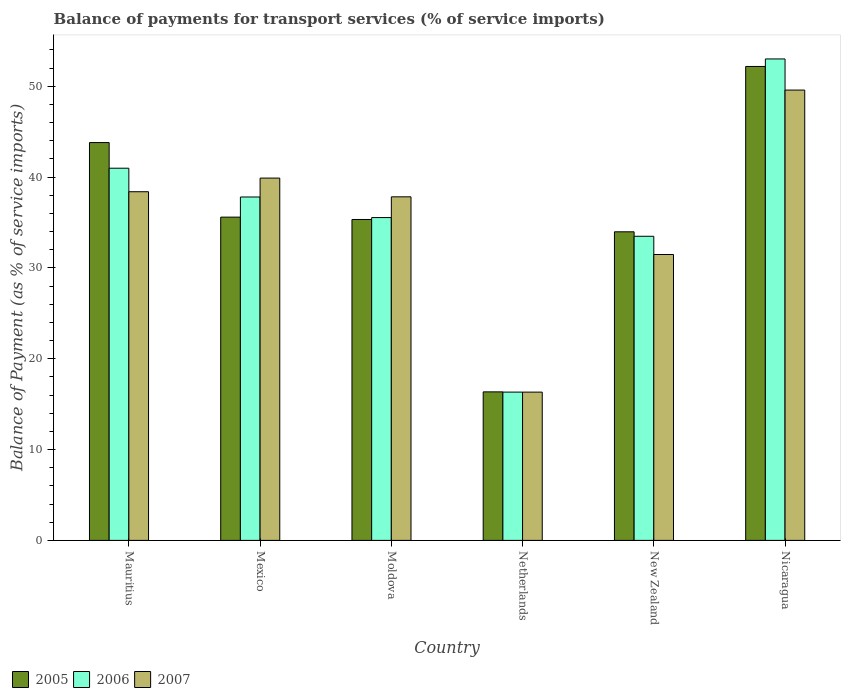How many different coloured bars are there?
Provide a succinct answer. 3. Are the number of bars per tick equal to the number of legend labels?
Make the answer very short. Yes. How many bars are there on the 4th tick from the left?
Offer a terse response. 3. What is the label of the 1st group of bars from the left?
Keep it short and to the point. Mauritius. In how many cases, is the number of bars for a given country not equal to the number of legend labels?
Your answer should be compact. 0. What is the balance of payments for transport services in 2006 in Mexico?
Your answer should be very brief. 37.81. Across all countries, what is the maximum balance of payments for transport services in 2006?
Your answer should be compact. 53.01. Across all countries, what is the minimum balance of payments for transport services in 2007?
Provide a succinct answer. 16.33. In which country was the balance of payments for transport services in 2007 maximum?
Give a very brief answer. Nicaragua. In which country was the balance of payments for transport services in 2006 minimum?
Provide a succinct answer. Netherlands. What is the total balance of payments for transport services in 2005 in the graph?
Provide a succinct answer. 217.26. What is the difference between the balance of payments for transport services in 2006 in Mexico and that in New Zealand?
Your answer should be very brief. 4.33. What is the difference between the balance of payments for transport services in 2005 in New Zealand and the balance of payments for transport services in 2006 in Mexico?
Give a very brief answer. -3.83. What is the average balance of payments for transport services in 2006 per country?
Keep it short and to the point. 36.2. What is the difference between the balance of payments for transport services of/in 2007 and balance of payments for transport services of/in 2006 in Mexico?
Your answer should be compact. 2.08. What is the ratio of the balance of payments for transport services in 2006 in Mauritius to that in Nicaragua?
Make the answer very short. 0.77. Is the balance of payments for transport services in 2006 in Mexico less than that in Moldova?
Give a very brief answer. No. Is the difference between the balance of payments for transport services in 2007 in Mexico and New Zealand greater than the difference between the balance of payments for transport services in 2006 in Mexico and New Zealand?
Provide a succinct answer. Yes. What is the difference between the highest and the second highest balance of payments for transport services in 2005?
Offer a terse response. -8.21. What is the difference between the highest and the lowest balance of payments for transport services in 2005?
Ensure brevity in your answer.  35.83. Is the sum of the balance of payments for transport services in 2007 in Moldova and New Zealand greater than the maximum balance of payments for transport services in 2006 across all countries?
Provide a short and direct response. Yes. What does the 2nd bar from the left in Netherlands represents?
Your response must be concise. 2006. What does the 2nd bar from the right in Nicaragua represents?
Make the answer very short. 2006. Is it the case that in every country, the sum of the balance of payments for transport services in 2007 and balance of payments for transport services in 2006 is greater than the balance of payments for transport services in 2005?
Ensure brevity in your answer.  Yes. How many countries are there in the graph?
Your answer should be very brief. 6. What is the difference between two consecutive major ticks on the Y-axis?
Provide a short and direct response. 10. Are the values on the major ticks of Y-axis written in scientific E-notation?
Offer a very short reply. No. Does the graph contain grids?
Offer a terse response. No. How many legend labels are there?
Make the answer very short. 3. How are the legend labels stacked?
Give a very brief answer. Horizontal. What is the title of the graph?
Keep it short and to the point. Balance of payments for transport services (% of service imports). What is the label or title of the Y-axis?
Offer a terse response. Balance of Payment (as % of service imports). What is the Balance of Payment (as % of service imports) of 2005 in Mauritius?
Ensure brevity in your answer.  43.81. What is the Balance of Payment (as % of service imports) in 2006 in Mauritius?
Ensure brevity in your answer.  40.98. What is the Balance of Payment (as % of service imports) of 2007 in Mauritius?
Give a very brief answer. 38.39. What is the Balance of Payment (as % of service imports) of 2005 in Mexico?
Make the answer very short. 35.6. What is the Balance of Payment (as % of service imports) in 2006 in Mexico?
Provide a short and direct response. 37.81. What is the Balance of Payment (as % of service imports) of 2007 in Mexico?
Provide a succinct answer. 39.9. What is the Balance of Payment (as % of service imports) of 2005 in Moldova?
Make the answer very short. 35.34. What is the Balance of Payment (as % of service imports) of 2006 in Moldova?
Your response must be concise. 35.55. What is the Balance of Payment (as % of service imports) of 2007 in Moldova?
Give a very brief answer. 37.83. What is the Balance of Payment (as % of service imports) in 2005 in Netherlands?
Offer a very short reply. 16.35. What is the Balance of Payment (as % of service imports) of 2006 in Netherlands?
Your answer should be compact. 16.33. What is the Balance of Payment (as % of service imports) in 2007 in Netherlands?
Provide a succinct answer. 16.33. What is the Balance of Payment (as % of service imports) in 2005 in New Zealand?
Provide a short and direct response. 33.98. What is the Balance of Payment (as % of service imports) in 2006 in New Zealand?
Provide a succinct answer. 33.49. What is the Balance of Payment (as % of service imports) in 2007 in New Zealand?
Offer a terse response. 31.48. What is the Balance of Payment (as % of service imports) in 2005 in Nicaragua?
Offer a terse response. 52.19. What is the Balance of Payment (as % of service imports) in 2006 in Nicaragua?
Give a very brief answer. 53.01. What is the Balance of Payment (as % of service imports) of 2007 in Nicaragua?
Make the answer very short. 49.59. Across all countries, what is the maximum Balance of Payment (as % of service imports) of 2005?
Your answer should be very brief. 52.19. Across all countries, what is the maximum Balance of Payment (as % of service imports) of 2006?
Your answer should be very brief. 53.01. Across all countries, what is the maximum Balance of Payment (as % of service imports) of 2007?
Ensure brevity in your answer.  49.59. Across all countries, what is the minimum Balance of Payment (as % of service imports) in 2005?
Provide a short and direct response. 16.35. Across all countries, what is the minimum Balance of Payment (as % of service imports) of 2006?
Your response must be concise. 16.33. Across all countries, what is the minimum Balance of Payment (as % of service imports) in 2007?
Your answer should be very brief. 16.33. What is the total Balance of Payment (as % of service imports) in 2005 in the graph?
Your response must be concise. 217.26. What is the total Balance of Payment (as % of service imports) in 2006 in the graph?
Offer a very short reply. 217.18. What is the total Balance of Payment (as % of service imports) of 2007 in the graph?
Your answer should be compact. 213.52. What is the difference between the Balance of Payment (as % of service imports) of 2005 in Mauritius and that in Mexico?
Make the answer very short. 8.21. What is the difference between the Balance of Payment (as % of service imports) of 2006 in Mauritius and that in Mexico?
Your response must be concise. 3.17. What is the difference between the Balance of Payment (as % of service imports) of 2007 in Mauritius and that in Mexico?
Make the answer very short. -1.5. What is the difference between the Balance of Payment (as % of service imports) of 2005 in Mauritius and that in Moldova?
Your answer should be very brief. 8.47. What is the difference between the Balance of Payment (as % of service imports) of 2006 in Mauritius and that in Moldova?
Your response must be concise. 5.43. What is the difference between the Balance of Payment (as % of service imports) of 2007 in Mauritius and that in Moldova?
Ensure brevity in your answer.  0.56. What is the difference between the Balance of Payment (as % of service imports) in 2005 in Mauritius and that in Netherlands?
Your response must be concise. 27.45. What is the difference between the Balance of Payment (as % of service imports) of 2006 in Mauritius and that in Netherlands?
Your answer should be compact. 24.65. What is the difference between the Balance of Payment (as % of service imports) in 2007 in Mauritius and that in Netherlands?
Provide a succinct answer. 22.07. What is the difference between the Balance of Payment (as % of service imports) in 2005 in Mauritius and that in New Zealand?
Your answer should be very brief. 9.83. What is the difference between the Balance of Payment (as % of service imports) of 2006 in Mauritius and that in New Zealand?
Your answer should be compact. 7.49. What is the difference between the Balance of Payment (as % of service imports) of 2007 in Mauritius and that in New Zealand?
Your answer should be compact. 6.91. What is the difference between the Balance of Payment (as % of service imports) of 2005 in Mauritius and that in Nicaragua?
Give a very brief answer. -8.38. What is the difference between the Balance of Payment (as % of service imports) in 2006 in Mauritius and that in Nicaragua?
Give a very brief answer. -12.03. What is the difference between the Balance of Payment (as % of service imports) in 2007 in Mauritius and that in Nicaragua?
Provide a succinct answer. -11.19. What is the difference between the Balance of Payment (as % of service imports) of 2005 in Mexico and that in Moldova?
Offer a very short reply. 0.26. What is the difference between the Balance of Payment (as % of service imports) in 2006 in Mexico and that in Moldova?
Keep it short and to the point. 2.27. What is the difference between the Balance of Payment (as % of service imports) of 2007 in Mexico and that in Moldova?
Your answer should be compact. 2.06. What is the difference between the Balance of Payment (as % of service imports) of 2005 in Mexico and that in Netherlands?
Make the answer very short. 19.24. What is the difference between the Balance of Payment (as % of service imports) in 2006 in Mexico and that in Netherlands?
Ensure brevity in your answer.  21.48. What is the difference between the Balance of Payment (as % of service imports) in 2007 in Mexico and that in Netherlands?
Provide a succinct answer. 23.57. What is the difference between the Balance of Payment (as % of service imports) of 2005 in Mexico and that in New Zealand?
Provide a succinct answer. 1.62. What is the difference between the Balance of Payment (as % of service imports) of 2006 in Mexico and that in New Zealand?
Make the answer very short. 4.33. What is the difference between the Balance of Payment (as % of service imports) of 2007 in Mexico and that in New Zealand?
Give a very brief answer. 8.42. What is the difference between the Balance of Payment (as % of service imports) of 2005 in Mexico and that in Nicaragua?
Your answer should be very brief. -16.59. What is the difference between the Balance of Payment (as % of service imports) in 2006 in Mexico and that in Nicaragua?
Your answer should be compact. -15.2. What is the difference between the Balance of Payment (as % of service imports) in 2007 in Mexico and that in Nicaragua?
Provide a short and direct response. -9.69. What is the difference between the Balance of Payment (as % of service imports) of 2005 in Moldova and that in Netherlands?
Your answer should be very brief. 18.98. What is the difference between the Balance of Payment (as % of service imports) in 2006 in Moldova and that in Netherlands?
Your answer should be compact. 19.22. What is the difference between the Balance of Payment (as % of service imports) of 2007 in Moldova and that in Netherlands?
Ensure brevity in your answer.  21.51. What is the difference between the Balance of Payment (as % of service imports) of 2005 in Moldova and that in New Zealand?
Your answer should be compact. 1.36. What is the difference between the Balance of Payment (as % of service imports) in 2006 in Moldova and that in New Zealand?
Your response must be concise. 2.06. What is the difference between the Balance of Payment (as % of service imports) in 2007 in Moldova and that in New Zealand?
Ensure brevity in your answer.  6.35. What is the difference between the Balance of Payment (as % of service imports) of 2005 in Moldova and that in Nicaragua?
Your answer should be compact. -16.85. What is the difference between the Balance of Payment (as % of service imports) of 2006 in Moldova and that in Nicaragua?
Make the answer very short. -17.47. What is the difference between the Balance of Payment (as % of service imports) in 2007 in Moldova and that in Nicaragua?
Your answer should be compact. -11.75. What is the difference between the Balance of Payment (as % of service imports) in 2005 in Netherlands and that in New Zealand?
Your answer should be compact. -17.63. What is the difference between the Balance of Payment (as % of service imports) in 2006 in Netherlands and that in New Zealand?
Ensure brevity in your answer.  -17.16. What is the difference between the Balance of Payment (as % of service imports) in 2007 in Netherlands and that in New Zealand?
Offer a terse response. -15.15. What is the difference between the Balance of Payment (as % of service imports) of 2005 in Netherlands and that in Nicaragua?
Your answer should be very brief. -35.83. What is the difference between the Balance of Payment (as % of service imports) in 2006 in Netherlands and that in Nicaragua?
Your response must be concise. -36.69. What is the difference between the Balance of Payment (as % of service imports) in 2007 in Netherlands and that in Nicaragua?
Your response must be concise. -33.26. What is the difference between the Balance of Payment (as % of service imports) in 2005 in New Zealand and that in Nicaragua?
Your response must be concise. -18.21. What is the difference between the Balance of Payment (as % of service imports) in 2006 in New Zealand and that in Nicaragua?
Offer a terse response. -19.53. What is the difference between the Balance of Payment (as % of service imports) in 2007 in New Zealand and that in Nicaragua?
Offer a terse response. -18.11. What is the difference between the Balance of Payment (as % of service imports) in 2005 in Mauritius and the Balance of Payment (as % of service imports) in 2006 in Mexico?
Offer a terse response. 5.99. What is the difference between the Balance of Payment (as % of service imports) in 2005 in Mauritius and the Balance of Payment (as % of service imports) in 2007 in Mexico?
Provide a short and direct response. 3.91. What is the difference between the Balance of Payment (as % of service imports) in 2006 in Mauritius and the Balance of Payment (as % of service imports) in 2007 in Mexico?
Provide a succinct answer. 1.09. What is the difference between the Balance of Payment (as % of service imports) of 2005 in Mauritius and the Balance of Payment (as % of service imports) of 2006 in Moldova?
Make the answer very short. 8.26. What is the difference between the Balance of Payment (as % of service imports) in 2005 in Mauritius and the Balance of Payment (as % of service imports) in 2007 in Moldova?
Offer a very short reply. 5.97. What is the difference between the Balance of Payment (as % of service imports) of 2006 in Mauritius and the Balance of Payment (as % of service imports) of 2007 in Moldova?
Ensure brevity in your answer.  3.15. What is the difference between the Balance of Payment (as % of service imports) of 2005 in Mauritius and the Balance of Payment (as % of service imports) of 2006 in Netherlands?
Your answer should be compact. 27.48. What is the difference between the Balance of Payment (as % of service imports) in 2005 in Mauritius and the Balance of Payment (as % of service imports) in 2007 in Netherlands?
Make the answer very short. 27.48. What is the difference between the Balance of Payment (as % of service imports) in 2006 in Mauritius and the Balance of Payment (as % of service imports) in 2007 in Netherlands?
Ensure brevity in your answer.  24.65. What is the difference between the Balance of Payment (as % of service imports) in 2005 in Mauritius and the Balance of Payment (as % of service imports) in 2006 in New Zealand?
Provide a succinct answer. 10.32. What is the difference between the Balance of Payment (as % of service imports) in 2005 in Mauritius and the Balance of Payment (as % of service imports) in 2007 in New Zealand?
Make the answer very short. 12.33. What is the difference between the Balance of Payment (as % of service imports) of 2006 in Mauritius and the Balance of Payment (as % of service imports) of 2007 in New Zealand?
Your answer should be very brief. 9.5. What is the difference between the Balance of Payment (as % of service imports) of 2005 in Mauritius and the Balance of Payment (as % of service imports) of 2006 in Nicaragua?
Give a very brief answer. -9.21. What is the difference between the Balance of Payment (as % of service imports) in 2005 in Mauritius and the Balance of Payment (as % of service imports) in 2007 in Nicaragua?
Your answer should be very brief. -5.78. What is the difference between the Balance of Payment (as % of service imports) of 2006 in Mauritius and the Balance of Payment (as % of service imports) of 2007 in Nicaragua?
Your answer should be very brief. -8.61. What is the difference between the Balance of Payment (as % of service imports) in 2005 in Mexico and the Balance of Payment (as % of service imports) in 2006 in Moldova?
Offer a very short reply. 0.05. What is the difference between the Balance of Payment (as % of service imports) in 2005 in Mexico and the Balance of Payment (as % of service imports) in 2007 in Moldova?
Make the answer very short. -2.24. What is the difference between the Balance of Payment (as % of service imports) in 2006 in Mexico and the Balance of Payment (as % of service imports) in 2007 in Moldova?
Make the answer very short. -0.02. What is the difference between the Balance of Payment (as % of service imports) of 2005 in Mexico and the Balance of Payment (as % of service imports) of 2006 in Netherlands?
Keep it short and to the point. 19.27. What is the difference between the Balance of Payment (as % of service imports) of 2005 in Mexico and the Balance of Payment (as % of service imports) of 2007 in Netherlands?
Your response must be concise. 19.27. What is the difference between the Balance of Payment (as % of service imports) of 2006 in Mexico and the Balance of Payment (as % of service imports) of 2007 in Netherlands?
Your answer should be compact. 21.49. What is the difference between the Balance of Payment (as % of service imports) in 2005 in Mexico and the Balance of Payment (as % of service imports) in 2006 in New Zealand?
Ensure brevity in your answer.  2.11. What is the difference between the Balance of Payment (as % of service imports) in 2005 in Mexico and the Balance of Payment (as % of service imports) in 2007 in New Zealand?
Offer a very short reply. 4.12. What is the difference between the Balance of Payment (as % of service imports) of 2006 in Mexico and the Balance of Payment (as % of service imports) of 2007 in New Zealand?
Make the answer very short. 6.33. What is the difference between the Balance of Payment (as % of service imports) of 2005 in Mexico and the Balance of Payment (as % of service imports) of 2006 in Nicaragua?
Provide a succinct answer. -17.42. What is the difference between the Balance of Payment (as % of service imports) in 2005 in Mexico and the Balance of Payment (as % of service imports) in 2007 in Nicaragua?
Make the answer very short. -13.99. What is the difference between the Balance of Payment (as % of service imports) of 2006 in Mexico and the Balance of Payment (as % of service imports) of 2007 in Nicaragua?
Provide a succinct answer. -11.77. What is the difference between the Balance of Payment (as % of service imports) in 2005 in Moldova and the Balance of Payment (as % of service imports) in 2006 in Netherlands?
Offer a terse response. 19.01. What is the difference between the Balance of Payment (as % of service imports) of 2005 in Moldova and the Balance of Payment (as % of service imports) of 2007 in Netherlands?
Provide a short and direct response. 19.01. What is the difference between the Balance of Payment (as % of service imports) of 2006 in Moldova and the Balance of Payment (as % of service imports) of 2007 in Netherlands?
Provide a succinct answer. 19.22. What is the difference between the Balance of Payment (as % of service imports) in 2005 in Moldova and the Balance of Payment (as % of service imports) in 2006 in New Zealand?
Give a very brief answer. 1.85. What is the difference between the Balance of Payment (as % of service imports) in 2005 in Moldova and the Balance of Payment (as % of service imports) in 2007 in New Zealand?
Offer a terse response. 3.86. What is the difference between the Balance of Payment (as % of service imports) of 2006 in Moldova and the Balance of Payment (as % of service imports) of 2007 in New Zealand?
Offer a very short reply. 4.07. What is the difference between the Balance of Payment (as % of service imports) in 2005 in Moldova and the Balance of Payment (as % of service imports) in 2006 in Nicaragua?
Ensure brevity in your answer.  -17.68. What is the difference between the Balance of Payment (as % of service imports) of 2005 in Moldova and the Balance of Payment (as % of service imports) of 2007 in Nicaragua?
Offer a terse response. -14.25. What is the difference between the Balance of Payment (as % of service imports) of 2006 in Moldova and the Balance of Payment (as % of service imports) of 2007 in Nicaragua?
Offer a terse response. -14.04. What is the difference between the Balance of Payment (as % of service imports) in 2005 in Netherlands and the Balance of Payment (as % of service imports) in 2006 in New Zealand?
Your answer should be very brief. -17.13. What is the difference between the Balance of Payment (as % of service imports) of 2005 in Netherlands and the Balance of Payment (as % of service imports) of 2007 in New Zealand?
Give a very brief answer. -15.13. What is the difference between the Balance of Payment (as % of service imports) in 2006 in Netherlands and the Balance of Payment (as % of service imports) in 2007 in New Zealand?
Ensure brevity in your answer.  -15.15. What is the difference between the Balance of Payment (as % of service imports) in 2005 in Netherlands and the Balance of Payment (as % of service imports) in 2006 in Nicaragua?
Offer a very short reply. -36.66. What is the difference between the Balance of Payment (as % of service imports) in 2005 in Netherlands and the Balance of Payment (as % of service imports) in 2007 in Nicaragua?
Offer a very short reply. -33.23. What is the difference between the Balance of Payment (as % of service imports) of 2006 in Netherlands and the Balance of Payment (as % of service imports) of 2007 in Nicaragua?
Your answer should be compact. -33.26. What is the difference between the Balance of Payment (as % of service imports) of 2005 in New Zealand and the Balance of Payment (as % of service imports) of 2006 in Nicaragua?
Give a very brief answer. -19.03. What is the difference between the Balance of Payment (as % of service imports) in 2005 in New Zealand and the Balance of Payment (as % of service imports) in 2007 in Nicaragua?
Offer a terse response. -15.61. What is the difference between the Balance of Payment (as % of service imports) in 2006 in New Zealand and the Balance of Payment (as % of service imports) in 2007 in Nicaragua?
Provide a short and direct response. -16.1. What is the average Balance of Payment (as % of service imports) in 2005 per country?
Your response must be concise. 36.21. What is the average Balance of Payment (as % of service imports) in 2006 per country?
Make the answer very short. 36.2. What is the average Balance of Payment (as % of service imports) in 2007 per country?
Keep it short and to the point. 35.59. What is the difference between the Balance of Payment (as % of service imports) in 2005 and Balance of Payment (as % of service imports) in 2006 in Mauritius?
Your response must be concise. 2.82. What is the difference between the Balance of Payment (as % of service imports) in 2005 and Balance of Payment (as % of service imports) in 2007 in Mauritius?
Make the answer very short. 5.41. What is the difference between the Balance of Payment (as % of service imports) in 2006 and Balance of Payment (as % of service imports) in 2007 in Mauritius?
Your answer should be compact. 2.59. What is the difference between the Balance of Payment (as % of service imports) of 2005 and Balance of Payment (as % of service imports) of 2006 in Mexico?
Keep it short and to the point. -2.22. What is the difference between the Balance of Payment (as % of service imports) of 2005 and Balance of Payment (as % of service imports) of 2007 in Mexico?
Your answer should be very brief. -4.3. What is the difference between the Balance of Payment (as % of service imports) of 2006 and Balance of Payment (as % of service imports) of 2007 in Mexico?
Give a very brief answer. -2.08. What is the difference between the Balance of Payment (as % of service imports) of 2005 and Balance of Payment (as % of service imports) of 2006 in Moldova?
Provide a short and direct response. -0.21. What is the difference between the Balance of Payment (as % of service imports) in 2005 and Balance of Payment (as % of service imports) in 2007 in Moldova?
Your response must be concise. -2.49. What is the difference between the Balance of Payment (as % of service imports) of 2006 and Balance of Payment (as % of service imports) of 2007 in Moldova?
Keep it short and to the point. -2.29. What is the difference between the Balance of Payment (as % of service imports) of 2005 and Balance of Payment (as % of service imports) of 2006 in Netherlands?
Ensure brevity in your answer.  0.03. What is the difference between the Balance of Payment (as % of service imports) of 2005 and Balance of Payment (as % of service imports) of 2007 in Netherlands?
Provide a succinct answer. 0.03. What is the difference between the Balance of Payment (as % of service imports) in 2006 and Balance of Payment (as % of service imports) in 2007 in Netherlands?
Provide a short and direct response. 0. What is the difference between the Balance of Payment (as % of service imports) in 2005 and Balance of Payment (as % of service imports) in 2006 in New Zealand?
Provide a short and direct response. 0.49. What is the difference between the Balance of Payment (as % of service imports) in 2005 and Balance of Payment (as % of service imports) in 2007 in New Zealand?
Offer a very short reply. 2.5. What is the difference between the Balance of Payment (as % of service imports) of 2006 and Balance of Payment (as % of service imports) of 2007 in New Zealand?
Provide a succinct answer. 2.01. What is the difference between the Balance of Payment (as % of service imports) in 2005 and Balance of Payment (as % of service imports) in 2006 in Nicaragua?
Give a very brief answer. -0.83. What is the difference between the Balance of Payment (as % of service imports) in 2005 and Balance of Payment (as % of service imports) in 2007 in Nicaragua?
Offer a very short reply. 2.6. What is the difference between the Balance of Payment (as % of service imports) of 2006 and Balance of Payment (as % of service imports) of 2007 in Nicaragua?
Your response must be concise. 3.43. What is the ratio of the Balance of Payment (as % of service imports) of 2005 in Mauritius to that in Mexico?
Provide a short and direct response. 1.23. What is the ratio of the Balance of Payment (as % of service imports) in 2006 in Mauritius to that in Mexico?
Your answer should be very brief. 1.08. What is the ratio of the Balance of Payment (as % of service imports) in 2007 in Mauritius to that in Mexico?
Your response must be concise. 0.96. What is the ratio of the Balance of Payment (as % of service imports) in 2005 in Mauritius to that in Moldova?
Offer a very short reply. 1.24. What is the ratio of the Balance of Payment (as % of service imports) in 2006 in Mauritius to that in Moldova?
Keep it short and to the point. 1.15. What is the ratio of the Balance of Payment (as % of service imports) of 2007 in Mauritius to that in Moldova?
Keep it short and to the point. 1.01. What is the ratio of the Balance of Payment (as % of service imports) of 2005 in Mauritius to that in Netherlands?
Ensure brevity in your answer.  2.68. What is the ratio of the Balance of Payment (as % of service imports) in 2006 in Mauritius to that in Netherlands?
Ensure brevity in your answer.  2.51. What is the ratio of the Balance of Payment (as % of service imports) in 2007 in Mauritius to that in Netherlands?
Keep it short and to the point. 2.35. What is the ratio of the Balance of Payment (as % of service imports) in 2005 in Mauritius to that in New Zealand?
Make the answer very short. 1.29. What is the ratio of the Balance of Payment (as % of service imports) of 2006 in Mauritius to that in New Zealand?
Keep it short and to the point. 1.22. What is the ratio of the Balance of Payment (as % of service imports) in 2007 in Mauritius to that in New Zealand?
Your answer should be very brief. 1.22. What is the ratio of the Balance of Payment (as % of service imports) of 2005 in Mauritius to that in Nicaragua?
Offer a very short reply. 0.84. What is the ratio of the Balance of Payment (as % of service imports) of 2006 in Mauritius to that in Nicaragua?
Provide a succinct answer. 0.77. What is the ratio of the Balance of Payment (as % of service imports) of 2007 in Mauritius to that in Nicaragua?
Make the answer very short. 0.77. What is the ratio of the Balance of Payment (as % of service imports) in 2005 in Mexico to that in Moldova?
Your answer should be compact. 1.01. What is the ratio of the Balance of Payment (as % of service imports) in 2006 in Mexico to that in Moldova?
Your response must be concise. 1.06. What is the ratio of the Balance of Payment (as % of service imports) of 2007 in Mexico to that in Moldova?
Give a very brief answer. 1.05. What is the ratio of the Balance of Payment (as % of service imports) of 2005 in Mexico to that in Netherlands?
Provide a succinct answer. 2.18. What is the ratio of the Balance of Payment (as % of service imports) of 2006 in Mexico to that in Netherlands?
Offer a very short reply. 2.32. What is the ratio of the Balance of Payment (as % of service imports) in 2007 in Mexico to that in Netherlands?
Your answer should be compact. 2.44. What is the ratio of the Balance of Payment (as % of service imports) in 2005 in Mexico to that in New Zealand?
Your answer should be compact. 1.05. What is the ratio of the Balance of Payment (as % of service imports) of 2006 in Mexico to that in New Zealand?
Offer a terse response. 1.13. What is the ratio of the Balance of Payment (as % of service imports) in 2007 in Mexico to that in New Zealand?
Your answer should be compact. 1.27. What is the ratio of the Balance of Payment (as % of service imports) of 2005 in Mexico to that in Nicaragua?
Offer a terse response. 0.68. What is the ratio of the Balance of Payment (as % of service imports) in 2006 in Mexico to that in Nicaragua?
Your answer should be compact. 0.71. What is the ratio of the Balance of Payment (as % of service imports) of 2007 in Mexico to that in Nicaragua?
Your answer should be very brief. 0.8. What is the ratio of the Balance of Payment (as % of service imports) in 2005 in Moldova to that in Netherlands?
Your answer should be very brief. 2.16. What is the ratio of the Balance of Payment (as % of service imports) in 2006 in Moldova to that in Netherlands?
Give a very brief answer. 2.18. What is the ratio of the Balance of Payment (as % of service imports) of 2007 in Moldova to that in Netherlands?
Provide a short and direct response. 2.32. What is the ratio of the Balance of Payment (as % of service imports) in 2005 in Moldova to that in New Zealand?
Offer a terse response. 1.04. What is the ratio of the Balance of Payment (as % of service imports) of 2006 in Moldova to that in New Zealand?
Offer a terse response. 1.06. What is the ratio of the Balance of Payment (as % of service imports) of 2007 in Moldova to that in New Zealand?
Give a very brief answer. 1.2. What is the ratio of the Balance of Payment (as % of service imports) in 2005 in Moldova to that in Nicaragua?
Offer a very short reply. 0.68. What is the ratio of the Balance of Payment (as % of service imports) in 2006 in Moldova to that in Nicaragua?
Give a very brief answer. 0.67. What is the ratio of the Balance of Payment (as % of service imports) of 2007 in Moldova to that in Nicaragua?
Offer a very short reply. 0.76. What is the ratio of the Balance of Payment (as % of service imports) of 2005 in Netherlands to that in New Zealand?
Provide a short and direct response. 0.48. What is the ratio of the Balance of Payment (as % of service imports) of 2006 in Netherlands to that in New Zealand?
Ensure brevity in your answer.  0.49. What is the ratio of the Balance of Payment (as % of service imports) of 2007 in Netherlands to that in New Zealand?
Offer a very short reply. 0.52. What is the ratio of the Balance of Payment (as % of service imports) in 2005 in Netherlands to that in Nicaragua?
Offer a terse response. 0.31. What is the ratio of the Balance of Payment (as % of service imports) of 2006 in Netherlands to that in Nicaragua?
Provide a succinct answer. 0.31. What is the ratio of the Balance of Payment (as % of service imports) in 2007 in Netherlands to that in Nicaragua?
Provide a succinct answer. 0.33. What is the ratio of the Balance of Payment (as % of service imports) in 2005 in New Zealand to that in Nicaragua?
Offer a terse response. 0.65. What is the ratio of the Balance of Payment (as % of service imports) in 2006 in New Zealand to that in Nicaragua?
Provide a succinct answer. 0.63. What is the ratio of the Balance of Payment (as % of service imports) in 2007 in New Zealand to that in Nicaragua?
Your answer should be very brief. 0.63. What is the difference between the highest and the second highest Balance of Payment (as % of service imports) of 2005?
Make the answer very short. 8.38. What is the difference between the highest and the second highest Balance of Payment (as % of service imports) of 2006?
Offer a very short reply. 12.03. What is the difference between the highest and the second highest Balance of Payment (as % of service imports) of 2007?
Your response must be concise. 9.69. What is the difference between the highest and the lowest Balance of Payment (as % of service imports) in 2005?
Provide a short and direct response. 35.83. What is the difference between the highest and the lowest Balance of Payment (as % of service imports) of 2006?
Keep it short and to the point. 36.69. What is the difference between the highest and the lowest Balance of Payment (as % of service imports) of 2007?
Your answer should be compact. 33.26. 